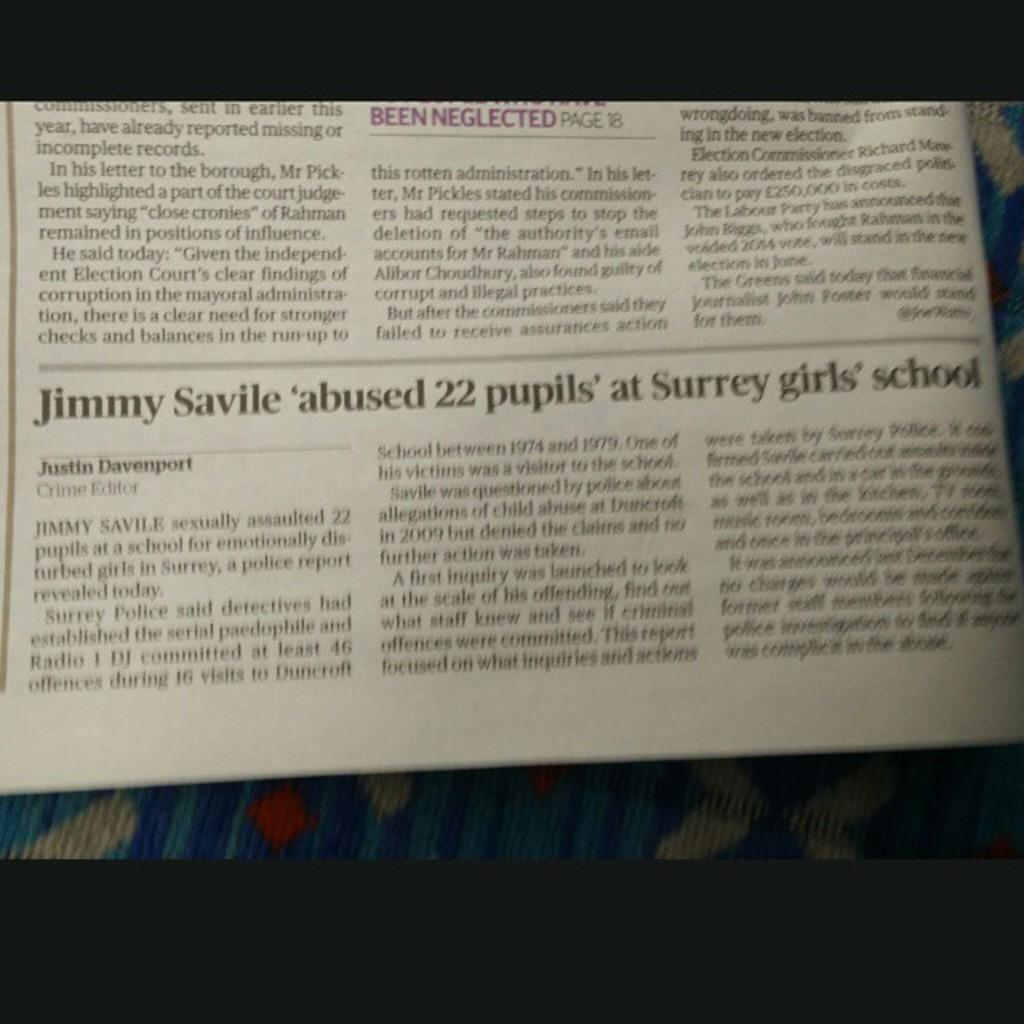<image>
Share a concise interpretation of the image provided. Newspaper headline that is saying that Jimmy Savile abused 22 pupils at Surrey Girls School. 